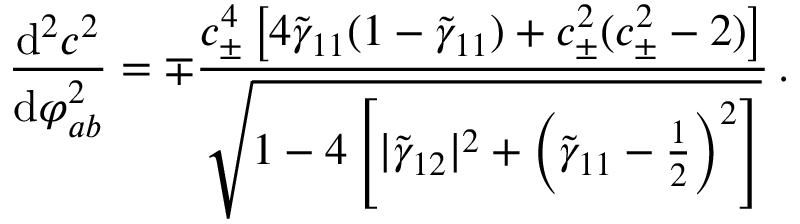<formula> <loc_0><loc_0><loc_500><loc_500>\frac { d ^ { 2 } c ^ { 2 } } { d \varphi _ { a b } ^ { 2 } } = \mp \frac { c _ { \pm } ^ { 4 } \left [ 4 \tilde { \gamma } _ { 1 1 } ( 1 - \tilde { \gamma } _ { 1 1 } ) + c _ { \pm } ^ { 2 } ( c _ { \pm } ^ { 2 } - 2 ) \right ] } { \sqrt { 1 - 4 \left [ | \tilde { \gamma } _ { 1 2 } | ^ { 2 } + \left ( \tilde { \gamma } _ { 1 1 } - \frac { 1 } { 2 } \right ) ^ { 2 } \right ] } } \, .</formula> 